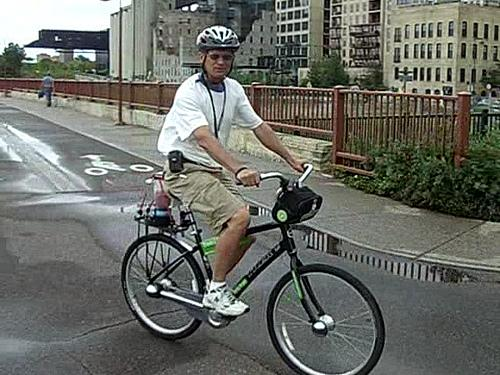What is above the bicycle?

Choices:
A) baby
B) old woman
C) man
D) cat man 